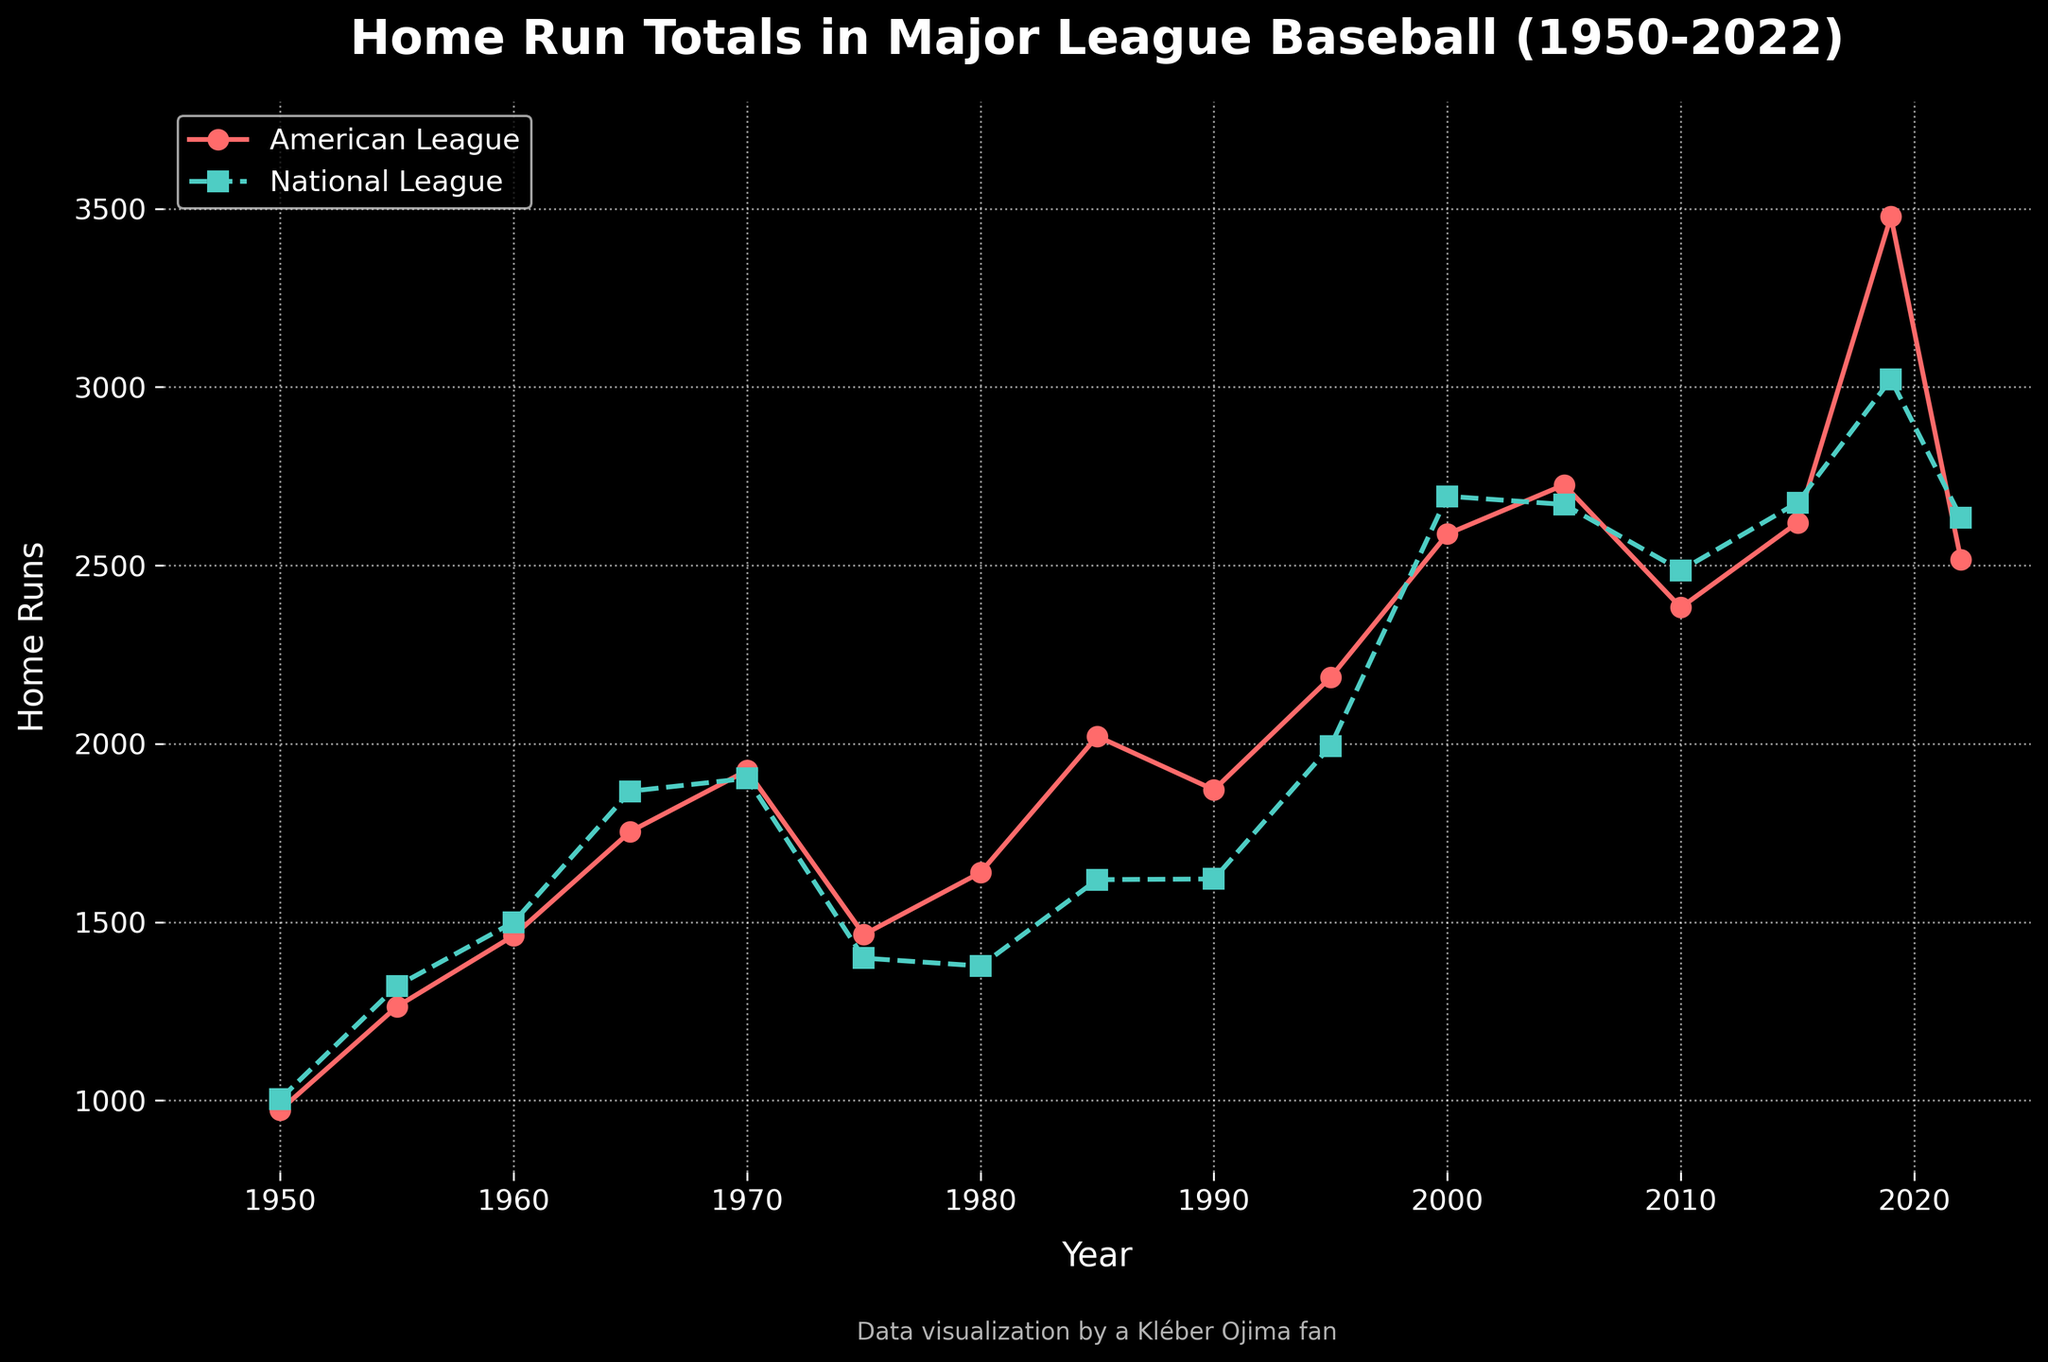Which league had more home runs in 1980? The figure shows home run totals for both leagues in each year. In 1980, the American League had around 1639 home runs, whereas the National League had around 1377 home runs. By comparing these values, we see that the American League had more home runs.
Answer: American League What is the trend in home run totals for the National League from 2000 to 2010? To identify the trend, look at the National League data points from the year 2000 to 2010. In 2000, the National League had around 2694 home runs. This number gradually decreased to around 2486 in 2010. Therefore, the trend for the National League in this period is a decrease in home run totals.
Answer: Decreasing Compare the home run totals of both leagues in 2019. Which league had more home runs and by how much? In 2019, the American League had approximately 3478 home runs, while the National League had around 3022 home runs. The difference between these values is 3478 - 3022 = 456. Thus, the American League had more home runs by 456.
Answer: American League, 456 What is the overall trend from 1950 to 2022 for the American League? Observing the American League data points from 1950 to 2022, we notice an overall increasing trend, with home run totals starting at around 973 in 1950 and rising up to around 2516 in 2022. Despite some fluctuations, the general direction is upward.
Answer: Increasing In which year did the National League experience its highest home run total according to the figure? To determine this, look at the plotted data for the National League and identify the highest data point. The peak value for the National League is around 3022 home runs in the year 2019.
Answer: 2019 Between which years did the American League experience the largest increase in home run totals? To find this, calculate the differences between consecutive data points for the American League. The largest increase appears between 2015 and 2019, where home runs jumped from around 2620 to 3478, which is an increase of 3478 - 2620 = 858.
Answer: 2015 to 2019 How did the trends of home run totals compare between the American and National Leagues from 1975 to 1985? From 1975 to 1985, we observe that both leagues had fluctuations, but the overall trend for the American League was an increase from around 1465 to 2021, while the National League also increased from around 1399 to 1619. Both leagues showed increasing trends, with the American League having a more significant rise.
Answer: Both increased, American League increased more What visual features indicate the difference between the data lines representing the American and National Leagues? The American League data line is identified by red color with circular markers, and the National League data line is green with square markers. Moreover, the American League line is continuous while the National League line is dashed. These visual attributes help distinguish between the two data sets.
Answer: Color, markers, line style Around what year did the American League first exceed 2000 home runs? By examining the figure, we see that the American League first exceeded 2000 home runs in the mid-1980s, specifically in 1985 when the home run total was around 2021.
Answer: 1985 